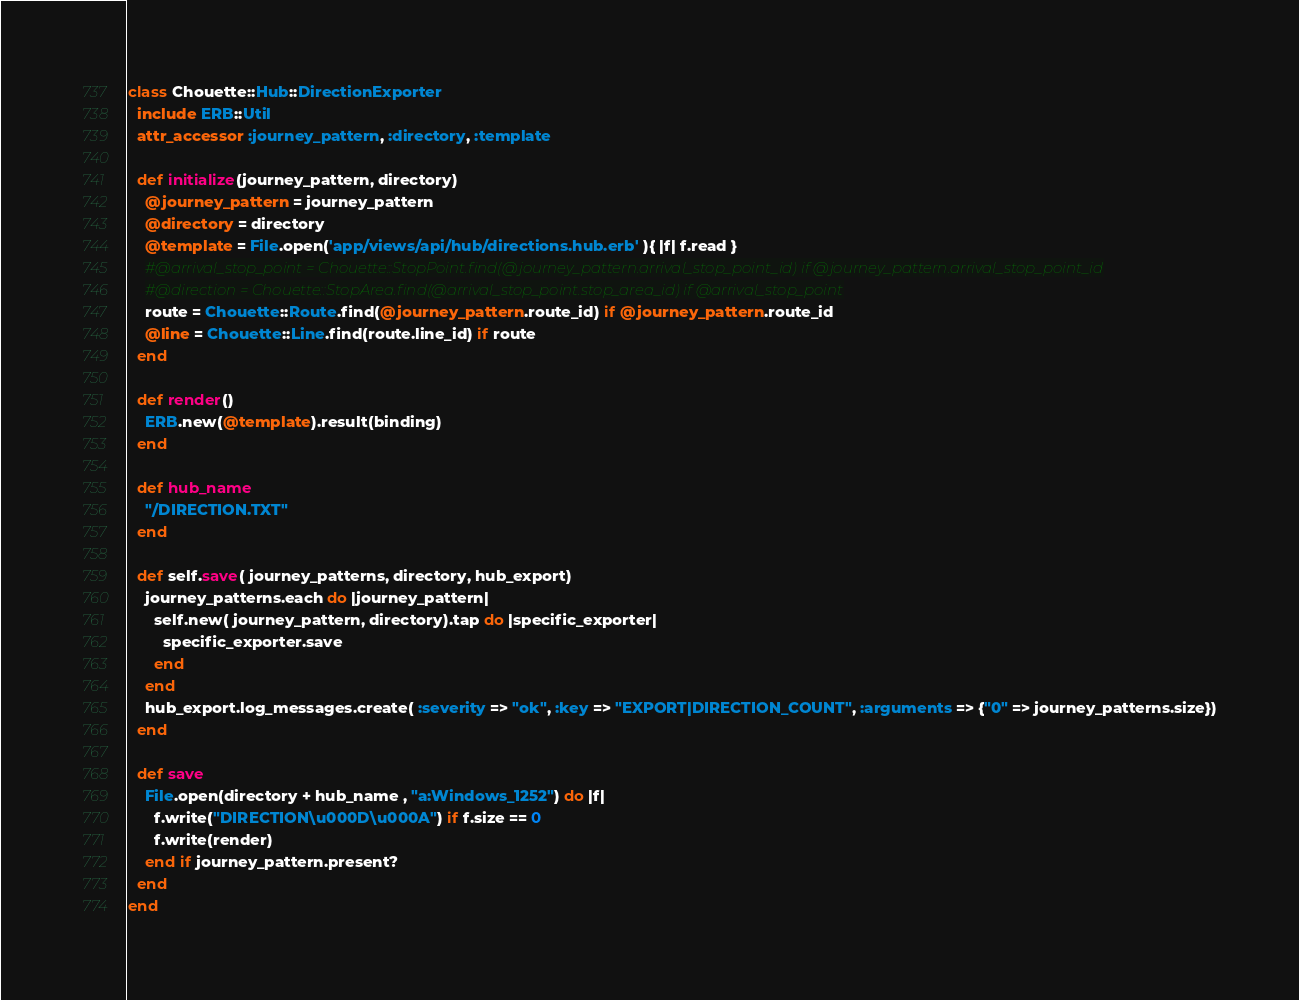Convert code to text. <code><loc_0><loc_0><loc_500><loc_500><_Ruby_>class Chouette::Hub::DirectionExporter
  include ERB::Util
  attr_accessor :journey_pattern, :directory, :template
  
  def initialize(journey_pattern, directory)
    @journey_pattern = journey_pattern
    @directory = directory
    @template = File.open('app/views/api/hub/directions.hub.erb' ){ |f| f.read }
    #@arrival_stop_point = Chouette::StopPoint.find(@journey_pattern.arrival_stop_point_id) if @journey_pattern.arrival_stop_point_id
    #@direction = Chouette::StopArea.find(@arrival_stop_point.stop_area_id) if @arrival_stop_point
    route = Chouette::Route.find(@journey_pattern.route_id) if @journey_pattern.route_id
    @line = Chouette::Line.find(route.line_id) if route
  end
  
  def render()
    ERB.new(@template).result(binding)
  end
  
  def hub_name
    "/DIRECTION.TXT"
  end
  
  def self.save( journey_patterns, directory, hub_export)
    journey_patterns.each do |journey_pattern|
      self.new( journey_pattern, directory).tap do |specific_exporter|
        specific_exporter.save
      end
    end
    hub_export.log_messages.create( :severity => "ok", :key => "EXPORT|DIRECTION_COUNT", :arguments => {"0" => journey_patterns.size})
  end
  
  def save
    File.open(directory + hub_name , "a:Windows_1252") do |f|
      f.write("DIRECTION\u000D\u000A") if f.size == 0
      f.write(render)
    end if journey_pattern.present?
  end
end

</code> 